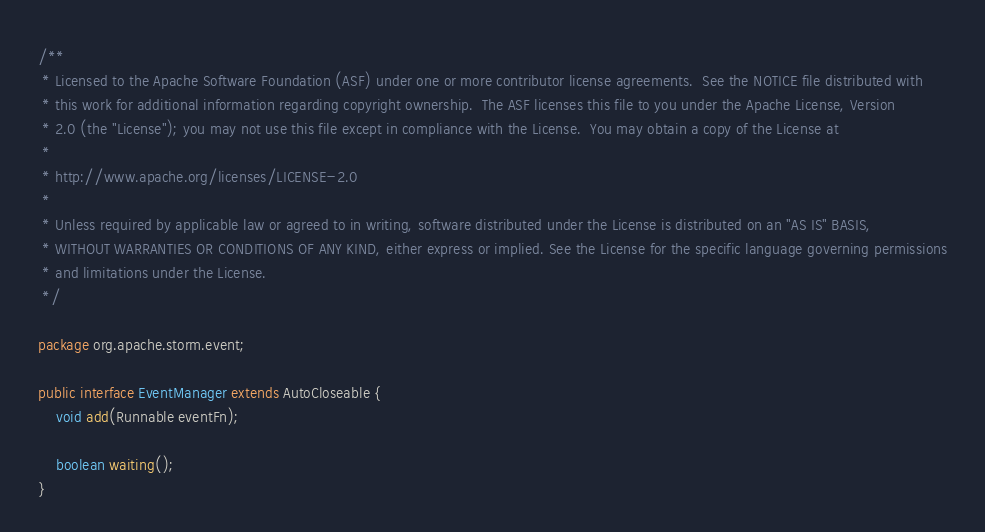Convert code to text. <code><loc_0><loc_0><loc_500><loc_500><_Java_>/**
 * Licensed to the Apache Software Foundation (ASF) under one or more contributor license agreements.  See the NOTICE file distributed with
 * this work for additional information regarding copyright ownership.  The ASF licenses this file to you under the Apache License, Version
 * 2.0 (the "License"); you may not use this file except in compliance with the License.  You may obtain a copy of the License at
 *
 * http://www.apache.org/licenses/LICENSE-2.0
 *
 * Unless required by applicable law or agreed to in writing, software distributed under the License is distributed on an "AS IS" BASIS,
 * WITHOUT WARRANTIES OR CONDITIONS OF ANY KIND, either express or implied. See the License for the specific language governing permissions
 * and limitations under the License.
 */

package org.apache.storm.event;

public interface EventManager extends AutoCloseable {
    void add(Runnable eventFn);

    boolean waiting();
}
</code> 